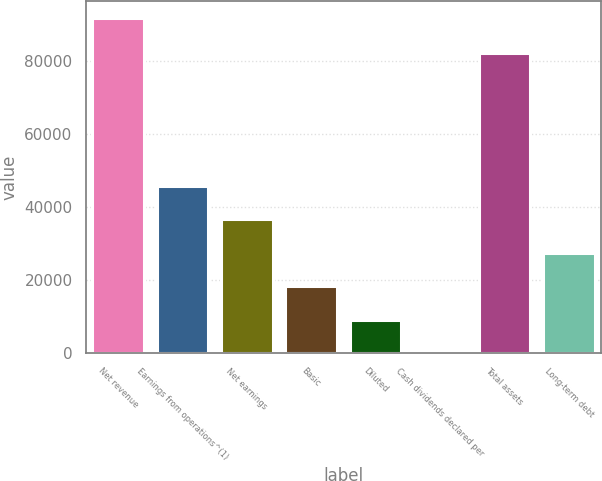<chart> <loc_0><loc_0><loc_500><loc_500><bar_chart><fcel>Net revenue<fcel>Earnings from operations^(1)<fcel>Net earnings<fcel>Basic<fcel>Diluted<fcel>Cash dividends declared per<fcel>Total assets<fcel>Long-term debt<nl><fcel>91658<fcel>45829.2<fcel>36663.4<fcel>18331.9<fcel>9166.09<fcel>0.32<fcel>81981<fcel>27497.6<nl></chart> 